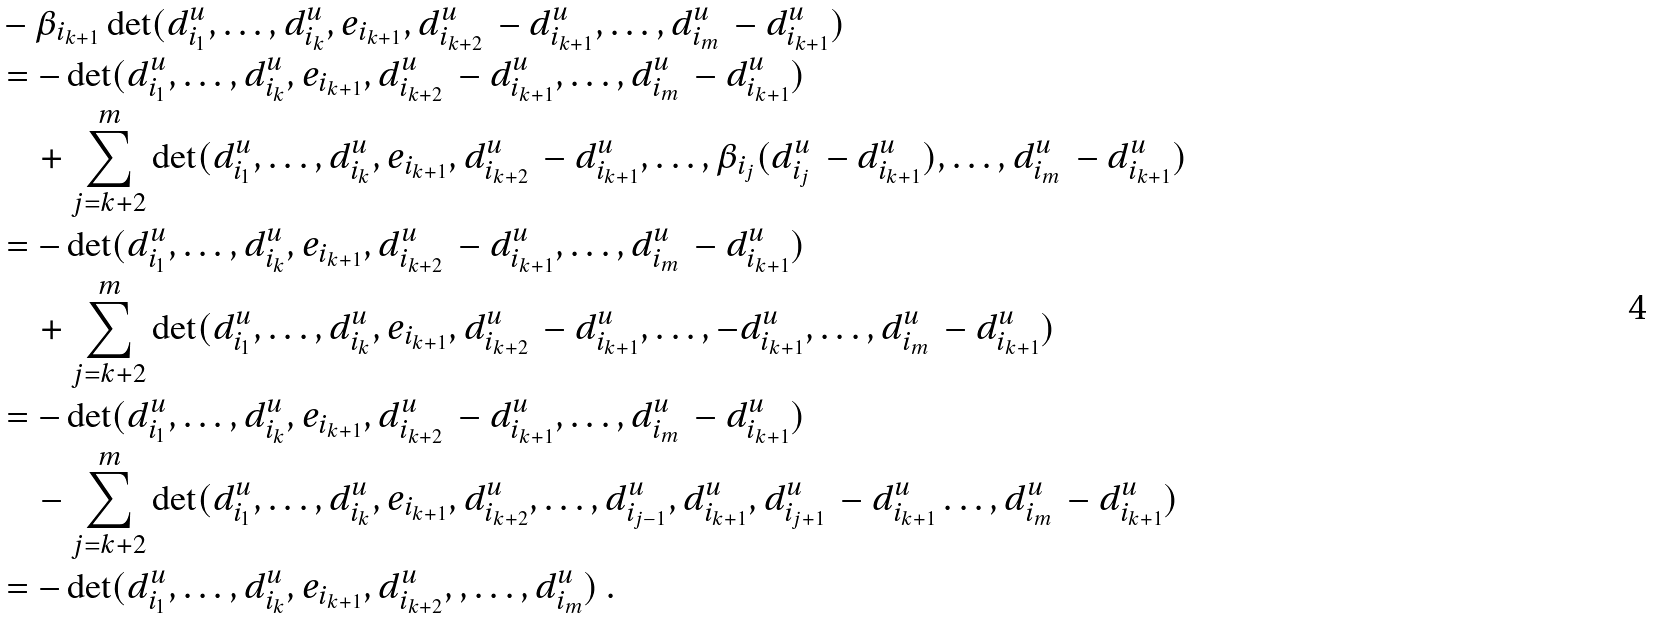Convert formula to latex. <formula><loc_0><loc_0><loc_500><loc_500>& - \beta _ { i _ { k + 1 } } \det ( d ^ { u } _ { i _ { 1 } } , \dots , d ^ { u } _ { i _ { k } } , e _ { i _ { k + 1 } } , d ^ { u } _ { i _ { k + 2 } } \, - d ^ { u } _ { i _ { k + 1 } } , \dots , d ^ { u } _ { i _ { m } } \, - d ^ { u } _ { i _ { k + 1 } } ) \\ & = - \det ( d ^ { u } _ { i _ { 1 } } , \dots , d ^ { u } _ { i _ { k } } , e _ { i _ { k + 1 } } , d ^ { u } _ { i _ { k + 2 } } \, - d ^ { u } _ { i _ { k + 1 } } , \dots , d ^ { u } _ { i _ { m } } \, - d ^ { u } _ { i _ { k + 1 } } ) \\ & \quad + \sum _ { j = k + 2 } ^ { m } \det ( d ^ { u } _ { i _ { 1 } } , \dots , d ^ { u } _ { i _ { k } } , e _ { i _ { k + 1 } } , d ^ { u } _ { i _ { k + 2 } } \, - d ^ { u } _ { i _ { k + 1 } } , \dots , \beta _ { i _ { j } } ( d ^ { u } _ { i _ { j } } \, - d ^ { u } _ { i _ { k + 1 } } ) , \dots , d ^ { u } _ { i _ { m } } \, - d ^ { u } _ { i _ { k + 1 } } ) \\ & = - \det ( d ^ { u } _ { i _ { 1 } } , \dots , d ^ { u } _ { i _ { k } } , e _ { i _ { k + 1 } } , d ^ { u } _ { i _ { k + 2 } } \, - d ^ { u } _ { i _ { k + 1 } } , \dots , d ^ { u } _ { i _ { m } } \, - d ^ { u } _ { i _ { k + 1 } } ) \\ & \quad + \sum _ { j = k + 2 } ^ { m } \det ( d ^ { u } _ { i _ { 1 } } , \dots , d ^ { u } _ { i _ { k } } , e _ { i _ { k + 1 } } , d ^ { u } _ { i _ { k + 2 } } \, - d ^ { u } _ { i _ { k + 1 } } , \dots , - d ^ { u } _ { i _ { k + 1 } } , \dots , d ^ { u } _ { i _ { m } } \, - d ^ { u } _ { i _ { k + 1 } } ) \\ & = - \det ( d ^ { u } _ { i _ { 1 } } , \dots , d ^ { u } _ { i _ { k } } , e _ { i _ { k + 1 } } , d ^ { u } _ { i _ { k + 2 } } \, - d ^ { u } _ { i _ { k + 1 } } , \dots , d ^ { u } _ { i _ { m } } \, - d ^ { u } _ { i _ { k + 1 } } ) \\ & \quad - \sum _ { j = k + 2 } ^ { m } \det ( d ^ { u } _ { i _ { 1 } } , \dots , d ^ { u } _ { i _ { k } } , e _ { i _ { k + 1 } } , d ^ { u } _ { i _ { k + 2 } } , \dots , d ^ { u } _ { i _ { j - 1 } } , d ^ { u } _ { i _ { k + 1 } } , d ^ { u } _ { i _ { j + 1 } } \, - d ^ { u } _ { i _ { k + 1 } } \dots , d ^ { u } _ { i _ { m } } \, - d ^ { u } _ { i _ { k + 1 } } ) \\ & = - \det ( d ^ { u } _ { i _ { 1 } } , \dots , d ^ { u } _ { i _ { k } } , e _ { i _ { k + 1 } } , d ^ { u } _ { i _ { k + 2 } } , , \dots , d ^ { u } _ { i _ { m } } ) \ .</formula> 